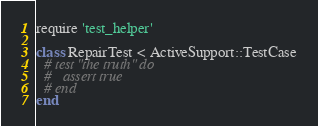<code> <loc_0><loc_0><loc_500><loc_500><_Ruby_>require 'test_helper'

class RepairTest < ActiveSupport::TestCase
  # test "the truth" do
  #   assert true
  # end
end
</code> 